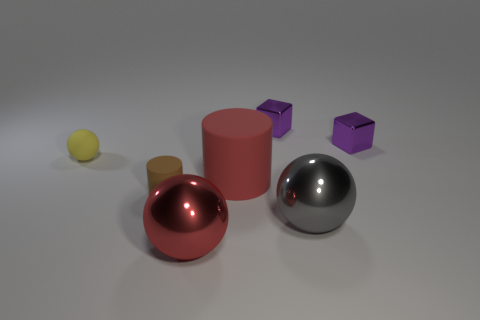Subtract all small rubber balls. How many balls are left? 2 Add 2 red metal spheres. How many objects exist? 9 Subtract all red cylinders. How many cylinders are left? 1 Subtract 2 cylinders. How many cylinders are left? 0 Add 1 rubber cylinders. How many rubber cylinders exist? 3 Subtract 0 gray cylinders. How many objects are left? 7 Subtract all balls. How many objects are left? 4 Subtract all brown spheres. Subtract all purple cylinders. How many spheres are left? 3 Subtract all red cylinders. How many red spheres are left? 1 Subtract all big green cylinders. Subtract all big matte objects. How many objects are left? 6 